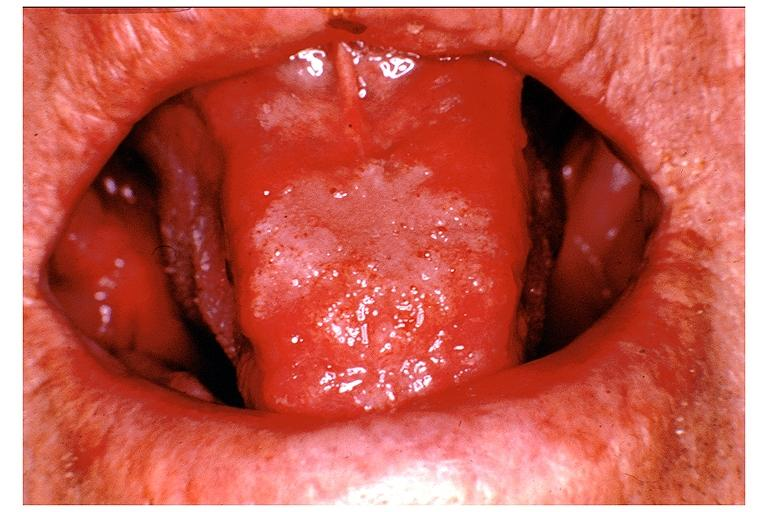does this image show blastomycosis?
Answer the question using a single word or phrase. Yes 